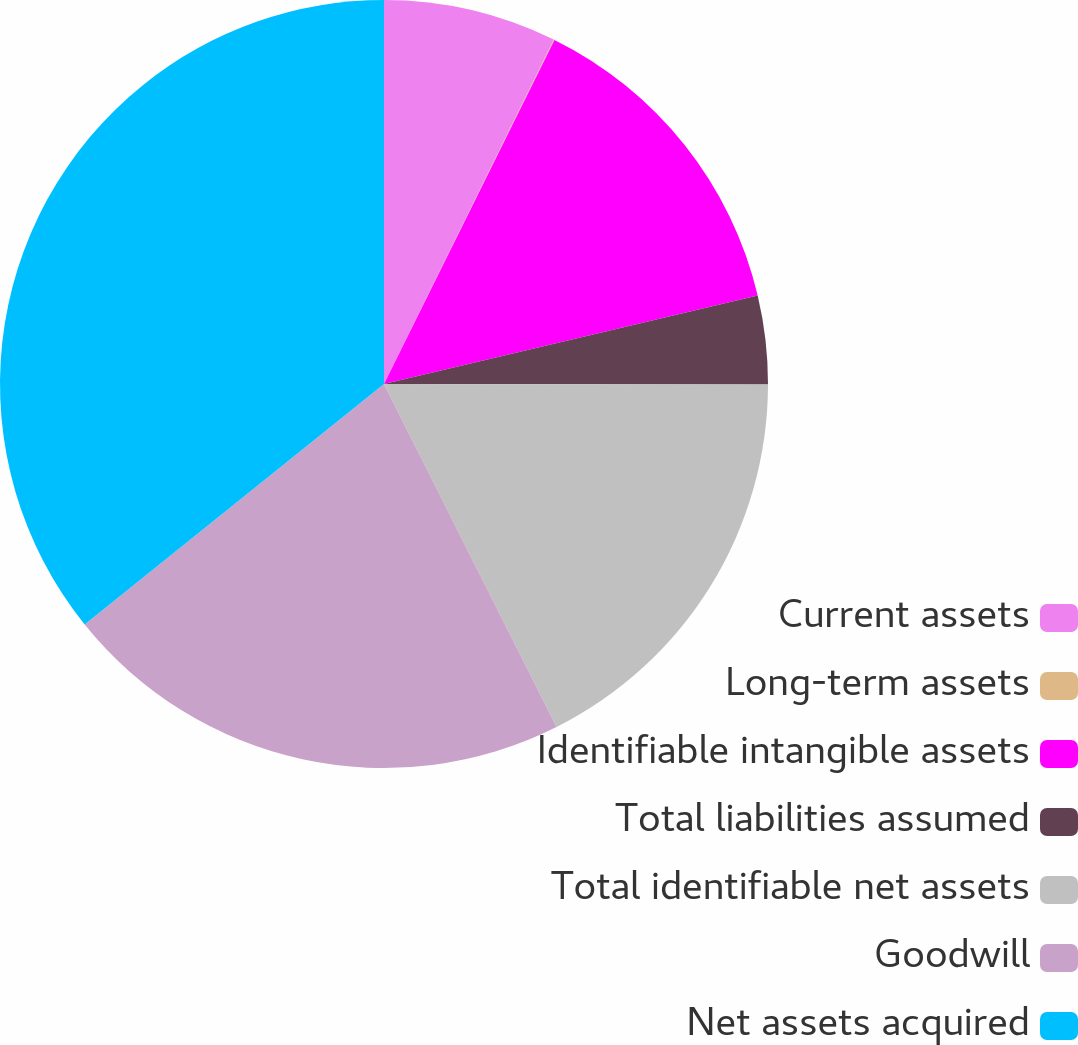<chart> <loc_0><loc_0><loc_500><loc_500><pie_chart><fcel>Current assets<fcel>Long-term assets<fcel>Identifiable intangible assets<fcel>Total liabilities assumed<fcel>Total identifiable net assets<fcel>Goodwill<fcel>Net assets acquired<nl><fcel>7.29%<fcel>0.03%<fcel>13.98%<fcel>3.72%<fcel>17.56%<fcel>21.64%<fcel>35.77%<nl></chart> 